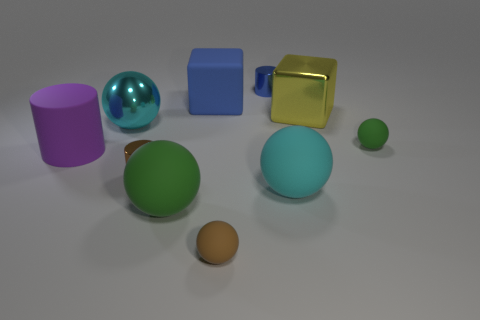Is there another yellow block made of the same material as the big yellow cube?
Offer a terse response. No. There is a rubber object on the left side of the small brown shiny cylinder; is its shape the same as the tiny blue metal thing?
Make the answer very short. Yes. There is a cyan ball right of the big shiny object left of the blue cylinder; how many rubber cubes are in front of it?
Give a very brief answer. 0. Is the number of small brown matte objects that are right of the cyan metal object less than the number of objects to the right of the tiny brown metallic cylinder?
Provide a short and direct response. Yes. There is another big matte object that is the same shape as the big yellow thing; what color is it?
Offer a very short reply. Blue. The blue cube has what size?
Make the answer very short. Large. What number of cyan matte blocks have the same size as the cyan matte ball?
Give a very brief answer. 0. Are the thing that is right of the metallic block and the large block on the right side of the tiny blue thing made of the same material?
Your answer should be very brief. No. Are there more large cyan matte things than big cyan cylinders?
Ensure brevity in your answer.  Yes. Is there anything else of the same color as the shiny ball?
Keep it short and to the point. Yes. 